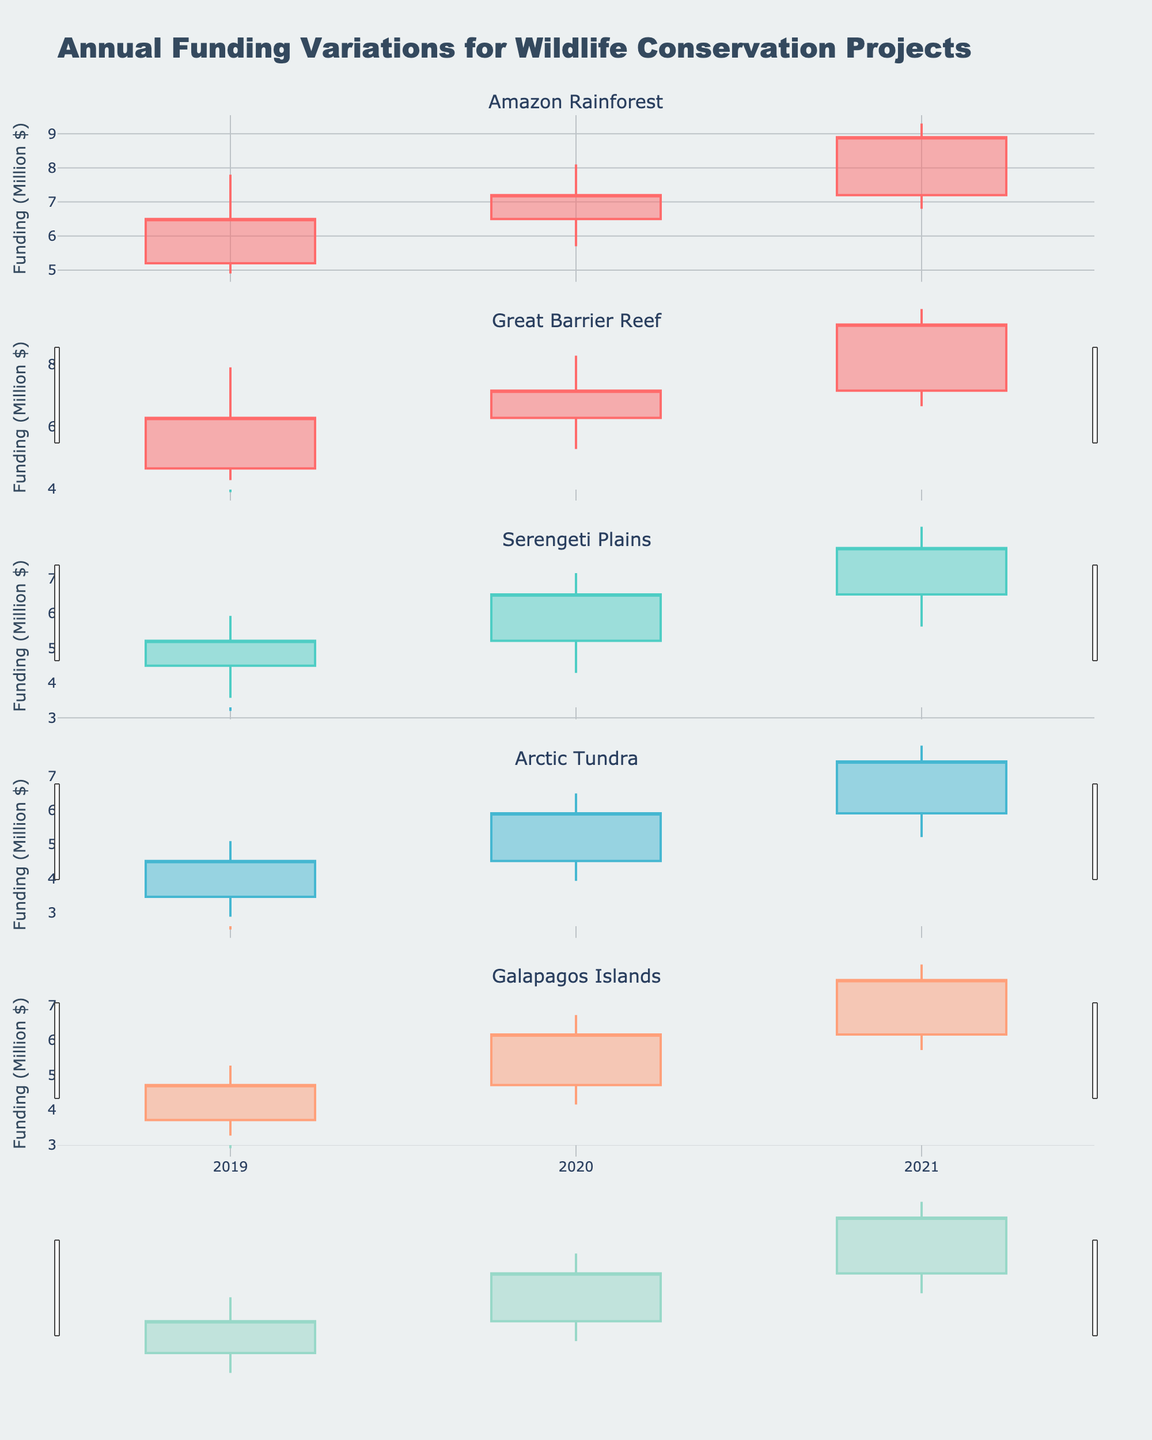Which ecosystem had the highest closing funding in 2021? The highest closing funding is found by comparing the closing values for each ecosystem in 2021. The values are: Amazon Rainforest (8.9), Great Barrier Reef (8.1), Serengeti Plains (7.1), Arctic Tundra (6.5), Galapagos Islands (6.8).
Answer: Amazon Rainforest What was the closing funding for the Arctic Tundra in 2020? The closing funding for the Arctic Tundra in 2020 can be directly read from the 2020 data row for the Arctic Tundra, which shows a closing value of 5.1.
Answer: 5.1 How did the funding for the Serengeti Plains change from 2019 to 2021? Calculate the difference in closing values for Serengeti Plains from 2019 (4.6) to 2021 (7.1): 7.1 - 4.6 = 2.5 million dollars.
Answer: Increased by 2.5 million dollars Among all the years displayed, which ecosystem shows the largest high value? To find the largest high value, compare the high values for all ecosystems across all years. The highest value among them is 9.3 (Amazon Rainforest in 2021).
Answer: Amazon Rainforest What is the average closing funding for the Galapagos Islands across the three years? The average closing funding is calculated by adding the closing values for the Galapagos Islands over 2019, 2020, and 2021, and then dividing by 3: (4.2 + 5.4 + 6.8) / 3 = 5.47 million dollars.
Answer: 5.47 Did any ecosystem experience a decrease in closing funding between any consecutive years? Look at changes in consecutive closing values. The Great Barrier Reef shows a decrease from 2020 (6.8) to 2021 (5.5).
Answer: Yes, Great Barrier Reef By how much did the funding for the Amazon Rainforest increase during the highest annual growth year? Find the year with the highest growth by subtracting consecutive closing values. For Amazon Rainforest, the difference is largest from 2020 to 2021: 8.9 - 7.2 = 1.7 million dollars.
Answer: 1.7 million dollars Which ecosystem had the smallest range (difference between high and low values) in funding in 2021? Calculate the range for each ecosystem in 2021: Amazon Rainforest (2.5), Great Barrier Reef (2.8), Serengeti Plains (2.3), Arctic Tundra (2.2), Galapagos Islands (2.3). The smallest range is for the Arctic Tundra (2.2).
Answer: Arctic Tundra 